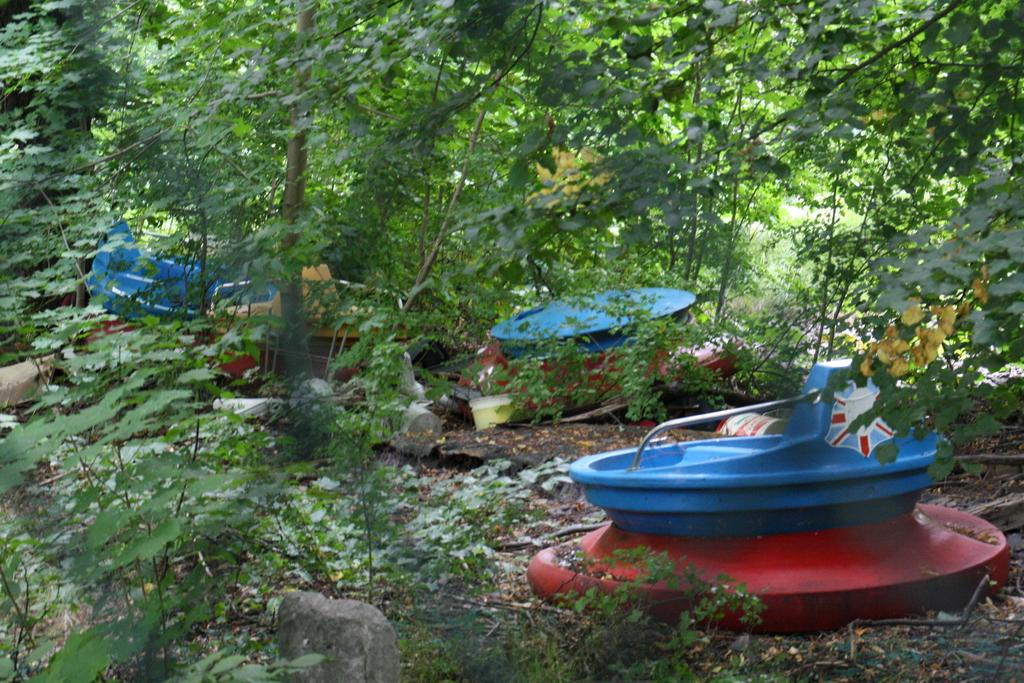What type of vehicles can be seen in the image? There are boats in the image. What other objects are present in the image besides the boats? There are stones, plants, and trees in the image. What is the surface on which the boats and other objects are situated? The ground is visible in the image. What type of lumber is being used to construct the boats in the image? There is no indication of the boats' construction materials in the image, so it cannot be determined from the image. 